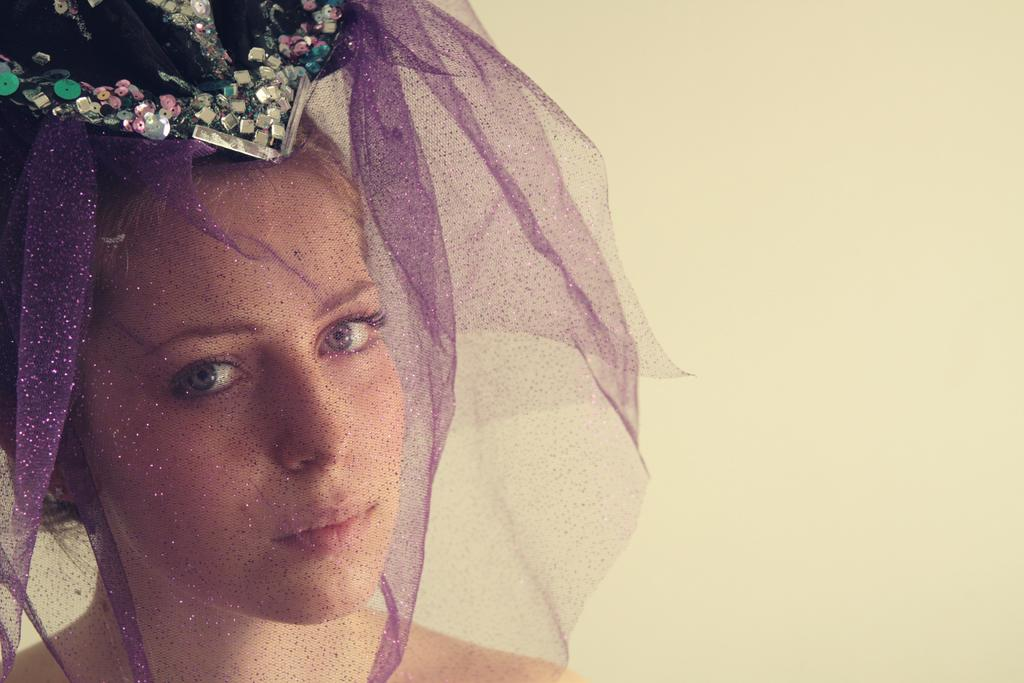Who is the main subject in the image? There is a lady in the image. What is the lady wearing on her head? The lady is wearing a crown. Can you describe the lady's face in the image? The lady's face is covered with a net. What can be seen in the background of the image? There is a wall in the background of the image. What type of kite is the lady flying in the image? There is no kite present in the image; the lady is wearing a crown and her face is covered with a net. 